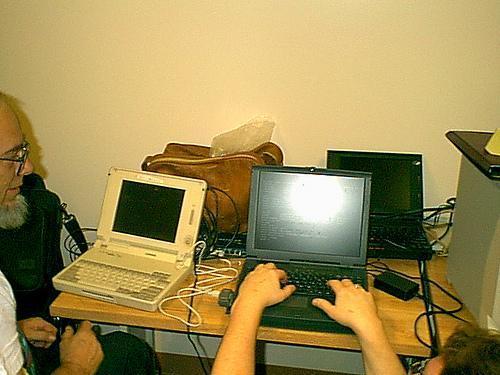How many laptops can be counted?
Give a very brief answer. 3. How many people can you see?
Give a very brief answer. 3. How many laptops are in the photo?
Give a very brief answer. 3. How many cows are in the photo?
Give a very brief answer. 0. 